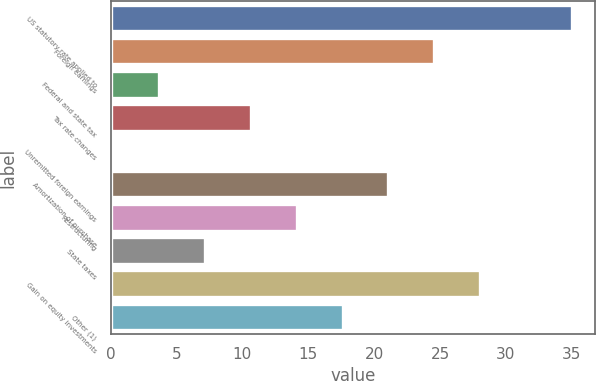Convert chart. <chart><loc_0><loc_0><loc_500><loc_500><bar_chart><fcel>US statutory rate applied to<fcel>Foreign earnings<fcel>Federal and state tax<fcel>Tax rate changes<fcel>Unremitted foreign earnings<fcel>Amortization of purchase<fcel>Restructuring<fcel>State taxes<fcel>Gain on equity investments<fcel>Other (1)<nl><fcel>35<fcel>24.56<fcel>3.68<fcel>10.64<fcel>0.2<fcel>21.08<fcel>14.12<fcel>7.16<fcel>28.04<fcel>17.6<nl></chart> 